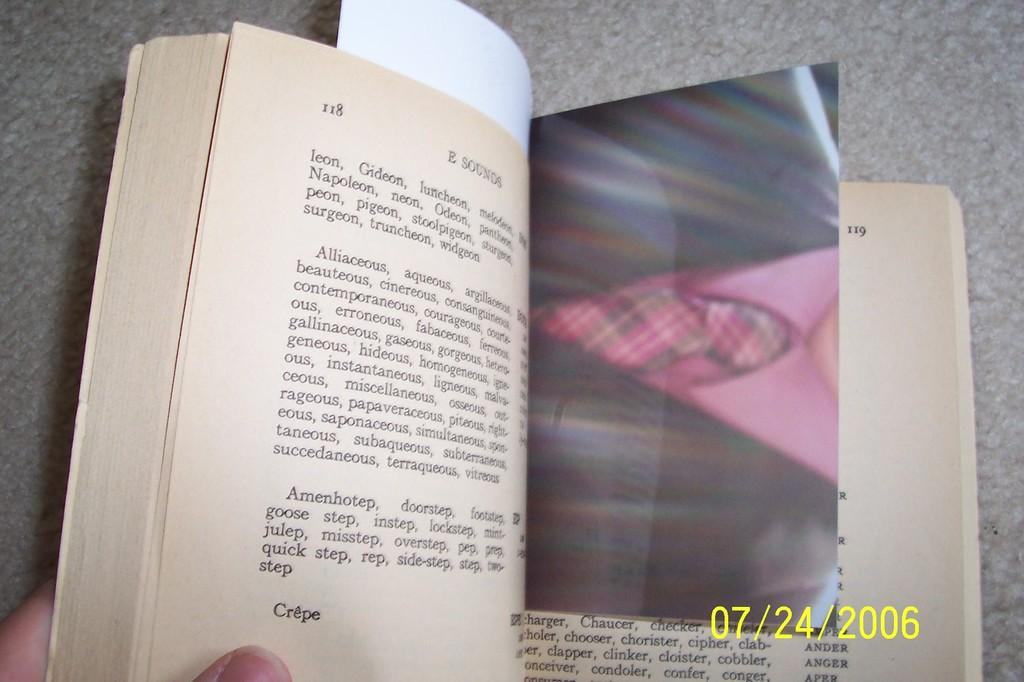<image>
Summarize the visual content of the image. an open book on page 118 with date stamp of 07/24/2006 on it 